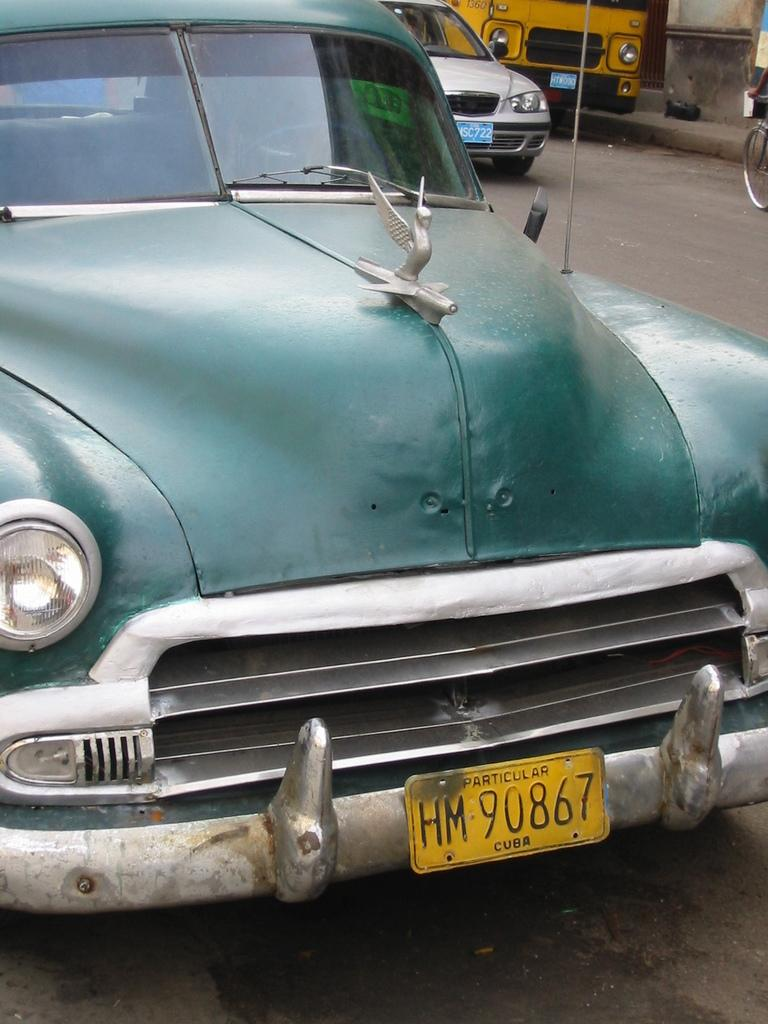<image>
Describe the image concisely. A battered old car is parked on a street in Cuba. 